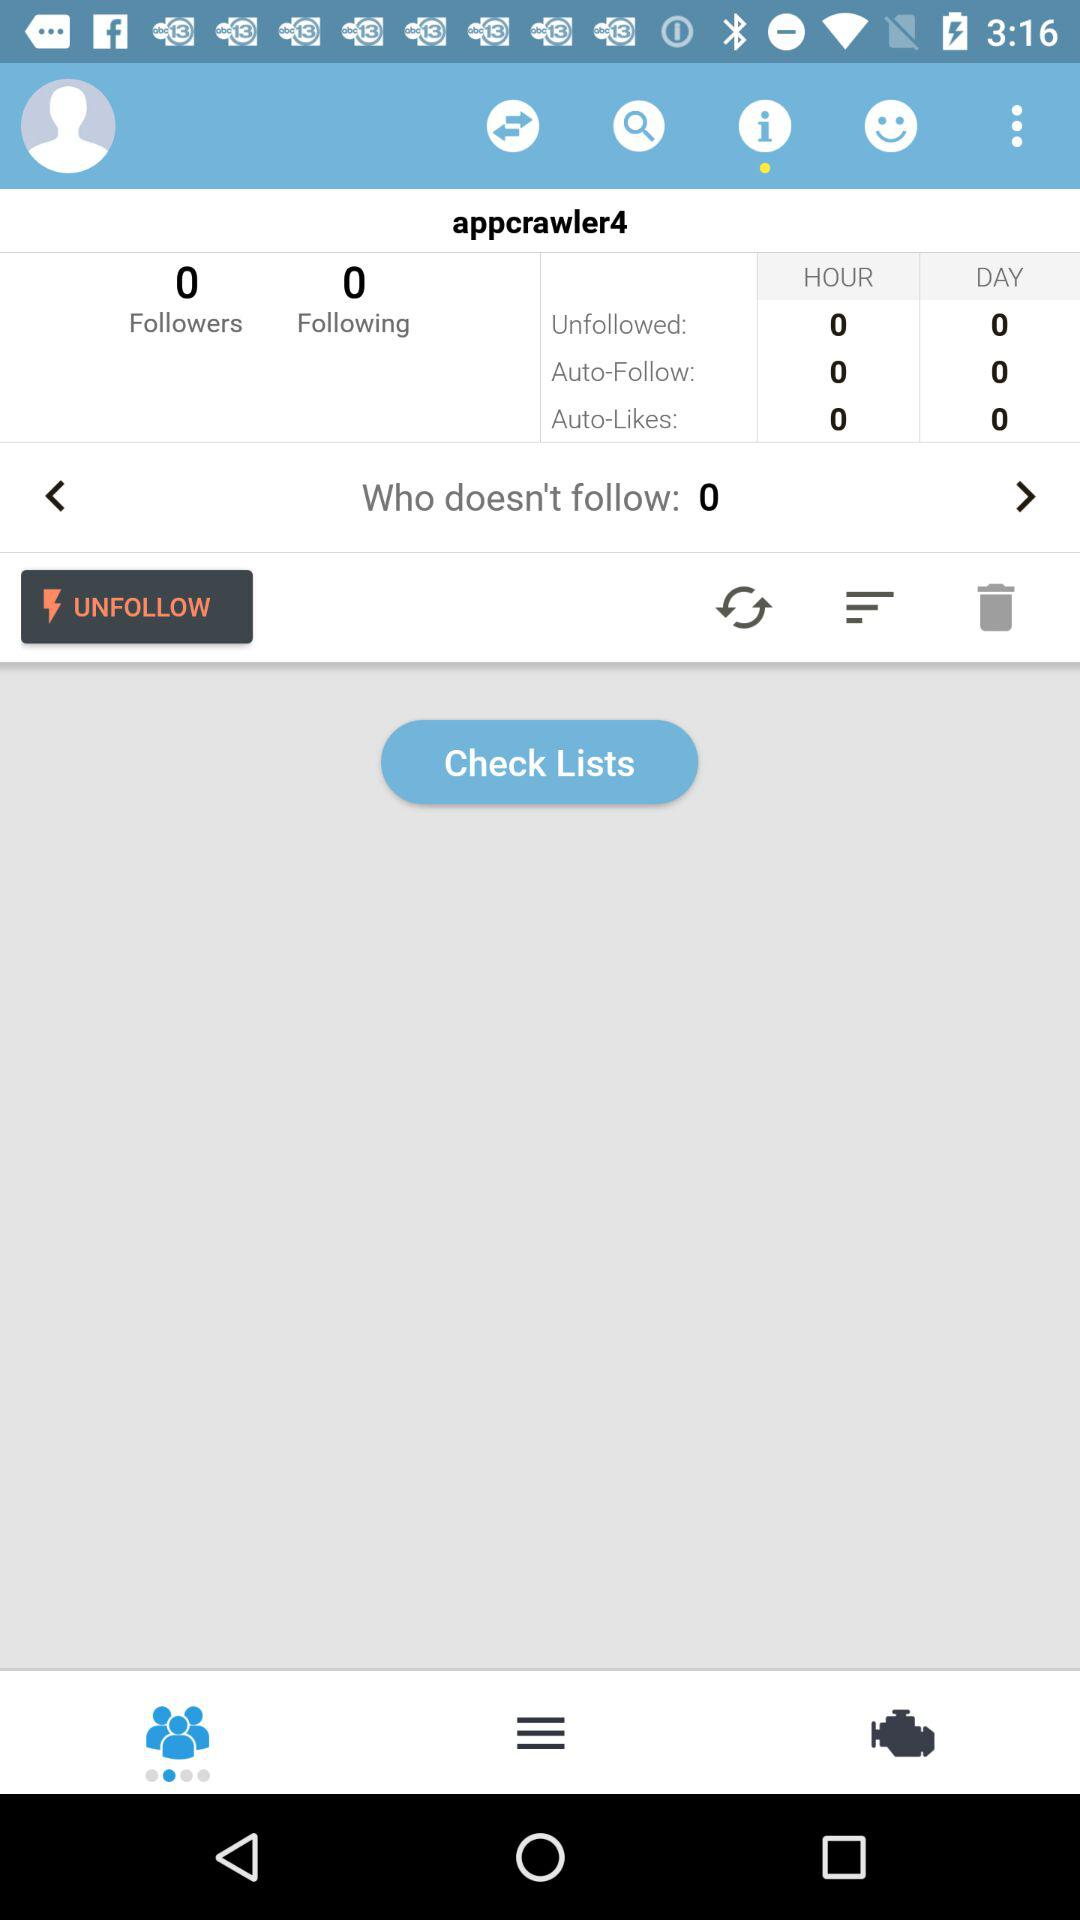What is the total number of people who follow you? The total number of people who follow you is 0. 